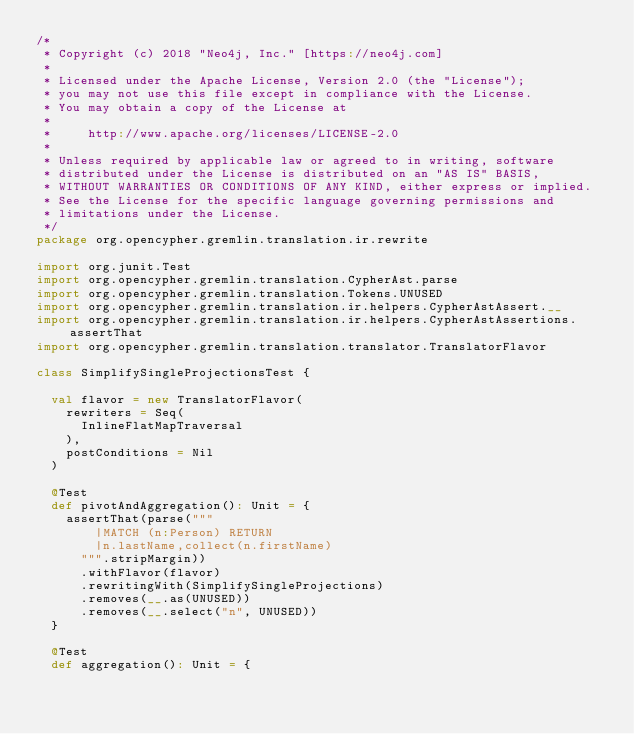<code> <loc_0><loc_0><loc_500><loc_500><_Scala_>/*
 * Copyright (c) 2018 "Neo4j, Inc." [https://neo4j.com]
 *
 * Licensed under the Apache License, Version 2.0 (the "License");
 * you may not use this file except in compliance with the License.
 * You may obtain a copy of the License at
 *
 *     http://www.apache.org/licenses/LICENSE-2.0
 *
 * Unless required by applicable law or agreed to in writing, software
 * distributed under the License is distributed on an "AS IS" BASIS,
 * WITHOUT WARRANTIES OR CONDITIONS OF ANY KIND, either express or implied.
 * See the License for the specific language governing permissions and
 * limitations under the License.
 */
package org.opencypher.gremlin.translation.ir.rewrite

import org.junit.Test
import org.opencypher.gremlin.translation.CypherAst.parse
import org.opencypher.gremlin.translation.Tokens.UNUSED
import org.opencypher.gremlin.translation.ir.helpers.CypherAstAssert.__
import org.opencypher.gremlin.translation.ir.helpers.CypherAstAssertions.assertThat
import org.opencypher.gremlin.translation.translator.TranslatorFlavor

class SimplifySingleProjectionsTest {

  val flavor = new TranslatorFlavor(
    rewriters = Seq(
      InlineFlatMapTraversal
    ),
    postConditions = Nil
  )

  @Test
  def pivotAndAggregation(): Unit = {
    assertThat(parse("""
        |MATCH (n:Person) RETURN
        |n.lastName,collect(n.firstName)
      """.stripMargin))
      .withFlavor(flavor)
      .rewritingWith(SimplifySingleProjections)
      .removes(__.as(UNUSED))
      .removes(__.select("n", UNUSED))
  }

  @Test
  def aggregation(): Unit = {</code> 